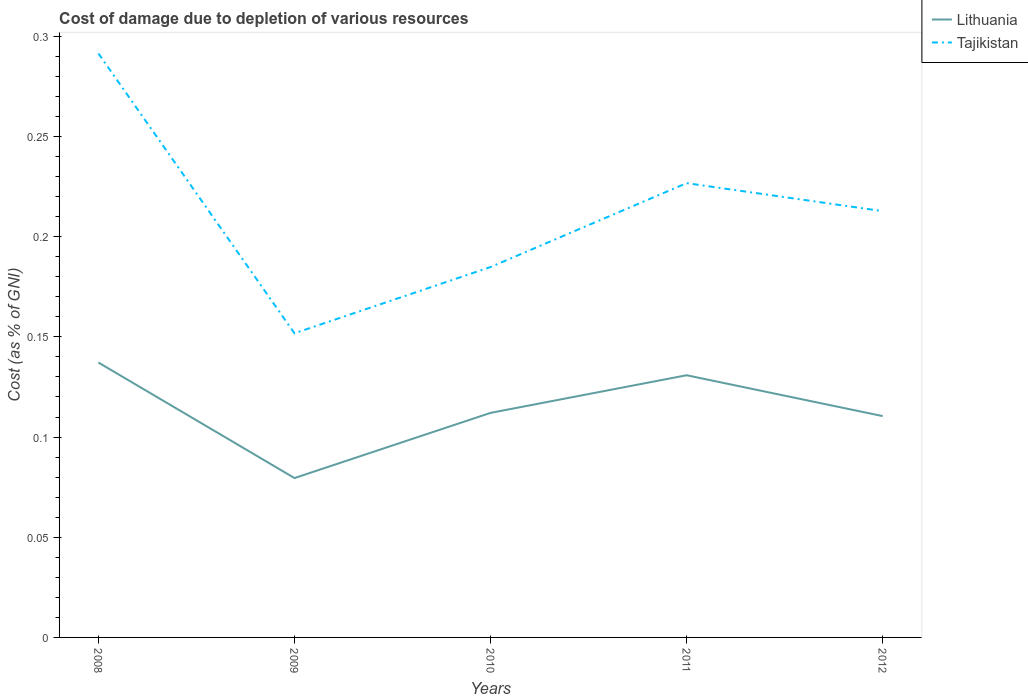Does the line corresponding to Lithuania intersect with the line corresponding to Tajikistan?
Make the answer very short. No. Is the number of lines equal to the number of legend labels?
Your answer should be compact. Yes. Across all years, what is the maximum cost of damage caused due to the depletion of various resources in Lithuania?
Offer a terse response. 0.08. In which year was the cost of damage caused due to the depletion of various resources in Lithuania maximum?
Ensure brevity in your answer.  2009. What is the total cost of damage caused due to the depletion of various resources in Tajikistan in the graph?
Provide a succinct answer. 0.11. What is the difference between the highest and the second highest cost of damage caused due to the depletion of various resources in Tajikistan?
Keep it short and to the point. 0.14. Is the cost of damage caused due to the depletion of various resources in Lithuania strictly greater than the cost of damage caused due to the depletion of various resources in Tajikistan over the years?
Make the answer very short. Yes. How many years are there in the graph?
Offer a very short reply. 5. What is the difference between two consecutive major ticks on the Y-axis?
Your answer should be compact. 0.05. Does the graph contain grids?
Ensure brevity in your answer.  No. How many legend labels are there?
Provide a short and direct response. 2. What is the title of the graph?
Your response must be concise. Cost of damage due to depletion of various resources. What is the label or title of the Y-axis?
Ensure brevity in your answer.  Cost (as % of GNI). What is the Cost (as % of GNI) in Lithuania in 2008?
Offer a very short reply. 0.14. What is the Cost (as % of GNI) in Tajikistan in 2008?
Offer a terse response. 0.29. What is the Cost (as % of GNI) of Lithuania in 2009?
Ensure brevity in your answer.  0.08. What is the Cost (as % of GNI) of Tajikistan in 2009?
Your answer should be compact. 0.15. What is the Cost (as % of GNI) in Lithuania in 2010?
Your answer should be compact. 0.11. What is the Cost (as % of GNI) of Tajikistan in 2010?
Keep it short and to the point. 0.18. What is the Cost (as % of GNI) in Lithuania in 2011?
Make the answer very short. 0.13. What is the Cost (as % of GNI) of Tajikistan in 2011?
Ensure brevity in your answer.  0.23. What is the Cost (as % of GNI) in Lithuania in 2012?
Your answer should be compact. 0.11. What is the Cost (as % of GNI) of Tajikistan in 2012?
Offer a terse response. 0.21. Across all years, what is the maximum Cost (as % of GNI) in Lithuania?
Offer a terse response. 0.14. Across all years, what is the maximum Cost (as % of GNI) of Tajikistan?
Your answer should be compact. 0.29. Across all years, what is the minimum Cost (as % of GNI) in Lithuania?
Your response must be concise. 0.08. Across all years, what is the minimum Cost (as % of GNI) of Tajikistan?
Your response must be concise. 0.15. What is the total Cost (as % of GNI) of Lithuania in the graph?
Your answer should be compact. 0.57. What is the total Cost (as % of GNI) of Tajikistan in the graph?
Offer a very short reply. 1.07. What is the difference between the Cost (as % of GNI) in Lithuania in 2008 and that in 2009?
Provide a succinct answer. 0.06. What is the difference between the Cost (as % of GNI) in Tajikistan in 2008 and that in 2009?
Your response must be concise. 0.14. What is the difference between the Cost (as % of GNI) of Lithuania in 2008 and that in 2010?
Offer a very short reply. 0.03. What is the difference between the Cost (as % of GNI) in Tajikistan in 2008 and that in 2010?
Keep it short and to the point. 0.11. What is the difference between the Cost (as % of GNI) in Lithuania in 2008 and that in 2011?
Your answer should be very brief. 0.01. What is the difference between the Cost (as % of GNI) in Tajikistan in 2008 and that in 2011?
Your response must be concise. 0.06. What is the difference between the Cost (as % of GNI) in Lithuania in 2008 and that in 2012?
Provide a short and direct response. 0.03. What is the difference between the Cost (as % of GNI) of Tajikistan in 2008 and that in 2012?
Provide a succinct answer. 0.08. What is the difference between the Cost (as % of GNI) in Lithuania in 2009 and that in 2010?
Your answer should be very brief. -0.03. What is the difference between the Cost (as % of GNI) of Tajikistan in 2009 and that in 2010?
Provide a short and direct response. -0.03. What is the difference between the Cost (as % of GNI) of Lithuania in 2009 and that in 2011?
Keep it short and to the point. -0.05. What is the difference between the Cost (as % of GNI) of Tajikistan in 2009 and that in 2011?
Provide a short and direct response. -0.07. What is the difference between the Cost (as % of GNI) in Lithuania in 2009 and that in 2012?
Provide a succinct answer. -0.03. What is the difference between the Cost (as % of GNI) in Tajikistan in 2009 and that in 2012?
Make the answer very short. -0.06. What is the difference between the Cost (as % of GNI) in Lithuania in 2010 and that in 2011?
Ensure brevity in your answer.  -0.02. What is the difference between the Cost (as % of GNI) in Tajikistan in 2010 and that in 2011?
Offer a very short reply. -0.04. What is the difference between the Cost (as % of GNI) of Lithuania in 2010 and that in 2012?
Your answer should be compact. 0. What is the difference between the Cost (as % of GNI) of Tajikistan in 2010 and that in 2012?
Keep it short and to the point. -0.03. What is the difference between the Cost (as % of GNI) in Lithuania in 2011 and that in 2012?
Your answer should be compact. 0.02. What is the difference between the Cost (as % of GNI) in Tajikistan in 2011 and that in 2012?
Offer a terse response. 0.01. What is the difference between the Cost (as % of GNI) of Lithuania in 2008 and the Cost (as % of GNI) of Tajikistan in 2009?
Your response must be concise. -0.01. What is the difference between the Cost (as % of GNI) in Lithuania in 2008 and the Cost (as % of GNI) in Tajikistan in 2010?
Keep it short and to the point. -0.05. What is the difference between the Cost (as % of GNI) in Lithuania in 2008 and the Cost (as % of GNI) in Tajikistan in 2011?
Provide a succinct answer. -0.09. What is the difference between the Cost (as % of GNI) of Lithuania in 2008 and the Cost (as % of GNI) of Tajikistan in 2012?
Make the answer very short. -0.08. What is the difference between the Cost (as % of GNI) in Lithuania in 2009 and the Cost (as % of GNI) in Tajikistan in 2010?
Offer a terse response. -0.11. What is the difference between the Cost (as % of GNI) in Lithuania in 2009 and the Cost (as % of GNI) in Tajikistan in 2011?
Your response must be concise. -0.15. What is the difference between the Cost (as % of GNI) of Lithuania in 2009 and the Cost (as % of GNI) of Tajikistan in 2012?
Your answer should be compact. -0.13. What is the difference between the Cost (as % of GNI) in Lithuania in 2010 and the Cost (as % of GNI) in Tajikistan in 2011?
Give a very brief answer. -0.11. What is the difference between the Cost (as % of GNI) of Lithuania in 2010 and the Cost (as % of GNI) of Tajikistan in 2012?
Offer a very short reply. -0.1. What is the difference between the Cost (as % of GNI) in Lithuania in 2011 and the Cost (as % of GNI) in Tajikistan in 2012?
Your answer should be compact. -0.08. What is the average Cost (as % of GNI) in Lithuania per year?
Offer a very short reply. 0.11. What is the average Cost (as % of GNI) of Tajikistan per year?
Your answer should be very brief. 0.21. In the year 2008, what is the difference between the Cost (as % of GNI) in Lithuania and Cost (as % of GNI) in Tajikistan?
Keep it short and to the point. -0.15. In the year 2009, what is the difference between the Cost (as % of GNI) of Lithuania and Cost (as % of GNI) of Tajikistan?
Make the answer very short. -0.07. In the year 2010, what is the difference between the Cost (as % of GNI) in Lithuania and Cost (as % of GNI) in Tajikistan?
Provide a short and direct response. -0.07. In the year 2011, what is the difference between the Cost (as % of GNI) in Lithuania and Cost (as % of GNI) in Tajikistan?
Make the answer very short. -0.1. In the year 2012, what is the difference between the Cost (as % of GNI) in Lithuania and Cost (as % of GNI) in Tajikistan?
Provide a short and direct response. -0.1. What is the ratio of the Cost (as % of GNI) in Lithuania in 2008 to that in 2009?
Your answer should be very brief. 1.72. What is the ratio of the Cost (as % of GNI) in Tajikistan in 2008 to that in 2009?
Give a very brief answer. 1.92. What is the ratio of the Cost (as % of GNI) of Lithuania in 2008 to that in 2010?
Ensure brevity in your answer.  1.22. What is the ratio of the Cost (as % of GNI) in Tajikistan in 2008 to that in 2010?
Give a very brief answer. 1.58. What is the ratio of the Cost (as % of GNI) in Lithuania in 2008 to that in 2011?
Provide a short and direct response. 1.05. What is the ratio of the Cost (as % of GNI) of Tajikistan in 2008 to that in 2011?
Your answer should be compact. 1.29. What is the ratio of the Cost (as % of GNI) in Lithuania in 2008 to that in 2012?
Your answer should be very brief. 1.24. What is the ratio of the Cost (as % of GNI) in Tajikistan in 2008 to that in 2012?
Offer a very short reply. 1.37. What is the ratio of the Cost (as % of GNI) of Lithuania in 2009 to that in 2010?
Your response must be concise. 0.71. What is the ratio of the Cost (as % of GNI) in Tajikistan in 2009 to that in 2010?
Provide a succinct answer. 0.82. What is the ratio of the Cost (as % of GNI) in Lithuania in 2009 to that in 2011?
Provide a short and direct response. 0.61. What is the ratio of the Cost (as % of GNI) of Tajikistan in 2009 to that in 2011?
Offer a terse response. 0.67. What is the ratio of the Cost (as % of GNI) in Lithuania in 2009 to that in 2012?
Provide a short and direct response. 0.72. What is the ratio of the Cost (as % of GNI) in Tajikistan in 2009 to that in 2012?
Provide a short and direct response. 0.71. What is the ratio of the Cost (as % of GNI) of Lithuania in 2010 to that in 2011?
Make the answer very short. 0.86. What is the ratio of the Cost (as % of GNI) in Tajikistan in 2010 to that in 2011?
Your answer should be very brief. 0.82. What is the ratio of the Cost (as % of GNI) in Lithuania in 2010 to that in 2012?
Ensure brevity in your answer.  1.01. What is the ratio of the Cost (as % of GNI) in Tajikistan in 2010 to that in 2012?
Your response must be concise. 0.87. What is the ratio of the Cost (as % of GNI) of Lithuania in 2011 to that in 2012?
Provide a succinct answer. 1.18. What is the ratio of the Cost (as % of GNI) of Tajikistan in 2011 to that in 2012?
Offer a very short reply. 1.07. What is the difference between the highest and the second highest Cost (as % of GNI) of Lithuania?
Your answer should be compact. 0.01. What is the difference between the highest and the second highest Cost (as % of GNI) of Tajikistan?
Offer a very short reply. 0.06. What is the difference between the highest and the lowest Cost (as % of GNI) in Lithuania?
Ensure brevity in your answer.  0.06. What is the difference between the highest and the lowest Cost (as % of GNI) in Tajikistan?
Offer a very short reply. 0.14. 